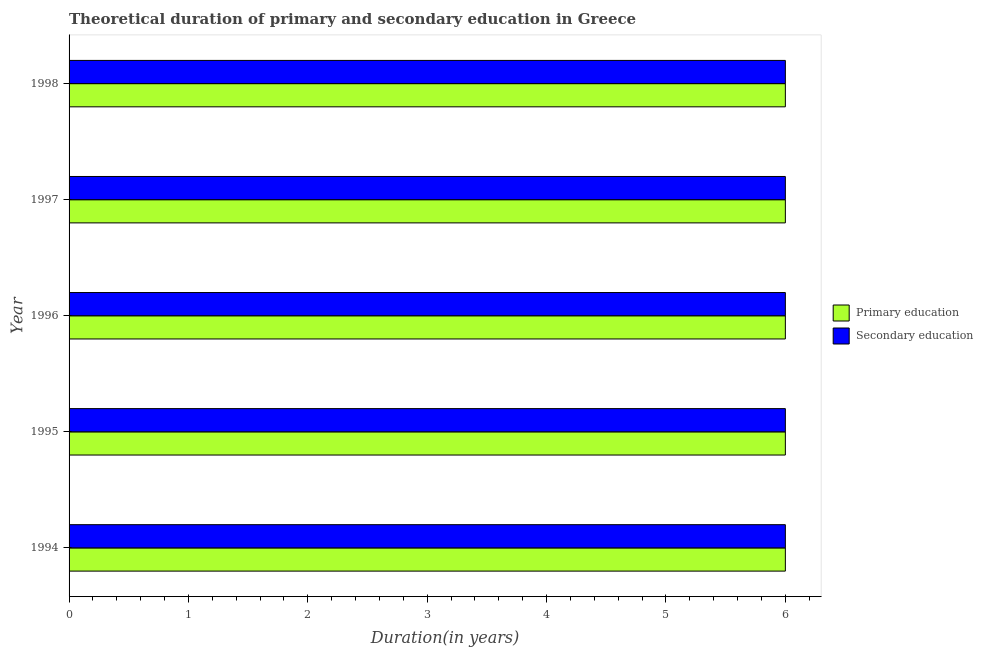How many groups of bars are there?
Keep it short and to the point. 5. Are the number of bars per tick equal to the number of legend labels?
Provide a short and direct response. Yes. How many bars are there on the 3rd tick from the top?
Your answer should be compact. 2. How many bars are there on the 5th tick from the bottom?
Offer a very short reply. 2. What is the label of the 5th group of bars from the top?
Your answer should be compact. 1994. In how many cases, is the number of bars for a given year not equal to the number of legend labels?
Provide a short and direct response. 0. Across all years, what is the minimum duration of secondary education?
Provide a short and direct response. 6. In which year was the duration of secondary education maximum?
Offer a very short reply. 1994. What is the total duration of secondary education in the graph?
Ensure brevity in your answer.  30. What is the average duration of secondary education per year?
Your answer should be compact. 6. In how many years, is the duration of primary education greater than 4.4 years?
Offer a terse response. 5. What is the ratio of the duration of secondary education in 1994 to that in 1995?
Your answer should be very brief. 1. Is the difference between the duration of secondary education in 1996 and 1997 greater than the difference between the duration of primary education in 1996 and 1997?
Make the answer very short. No. In how many years, is the duration of secondary education greater than the average duration of secondary education taken over all years?
Your answer should be compact. 0. What does the 1st bar from the top in 1998 represents?
Your response must be concise. Secondary education. What does the 1st bar from the bottom in 1995 represents?
Keep it short and to the point. Primary education. How many bars are there?
Make the answer very short. 10. Are the values on the major ticks of X-axis written in scientific E-notation?
Offer a very short reply. No. Does the graph contain any zero values?
Your answer should be very brief. No. Does the graph contain grids?
Keep it short and to the point. No. Where does the legend appear in the graph?
Offer a very short reply. Center right. How are the legend labels stacked?
Make the answer very short. Vertical. What is the title of the graph?
Your answer should be compact. Theoretical duration of primary and secondary education in Greece. Does "Net savings(excluding particulate emission damage)" appear as one of the legend labels in the graph?
Keep it short and to the point. No. What is the label or title of the X-axis?
Offer a very short reply. Duration(in years). What is the Duration(in years) of Primary education in 1995?
Provide a succinct answer. 6. What is the Duration(in years) in Secondary education in 1995?
Keep it short and to the point. 6. What is the Duration(in years) of Primary education in 1997?
Your response must be concise. 6. What is the Duration(in years) of Primary education in 1998?
Provide a short and direct response. 6. Across all years, what is the maximum Duration(in years) in Primary education?
Provide a short and direct response. 6. Across all years, what is the maximum Duration(in years) in Secondary education?
Offer a very short reply. 6. Across all years, what is the minimum Duration(in years) of Primary education?
Offer a terse response. 6. What is the total Duration(in years) in Primary education in the graph?
Give a very brief answer. 30. What is the total Duration(in years) in Secondary education in the graph?
Ensure brevity in your answer.  30. What is the difference between the Duration(in years) in Secondary education in 1994 and that in 1995?
Give a very brief answer. 0. What is the difference between the Duration(in years) in Primary education in 1994 and that in 1996?
Provide a short and direct response. 0. What is the difference between the Duration(in years) in Primary education in 1994 and that in 1997?
Your answer should be compact. 0. What is the difference between the Duration(in years) in Secondary education in 1994 and that in 1998?
Your answer should be very brief. 0. What is the difference between the Duration(in years) in Primary education in 1995 and that in 1996?
Provide a short and direct response. 0. What is the difference between the Duration(in years) in Primary education in 1995 and that in 1997?
Your answer should be very brief. 0. What is the difference between the Duration(in years) of Secondary education in 1997 and that in 1998?
Your response must be concise. 0. What is the difference between the Duration(in years) in Primary education in 1994 and the Duration(in years) in Secondary education in 1997?
Provide a short and direct response. 0. What is the difference between the Duration(in years) in Primary education in 1994 and the Duration(in years) in Secondary education in 1998?
Ensure brevity in your answer.  0. What is the difference between the Duration(in years) of Primary education in 1995 and the Duration(in years) of Secondary education in 1996?
Provide a short and direct response. 0. What is the difference between the Duration(in years) of Primary education in 1995 and the Duration(in years) of Secondary education in 1998?
Your answer should be compact. 0. What is the difference between the Duration(in years) in Primary education in 1996 and the Duration(in years) in Secondary education in 1997?
Keep it short and to the point. 0. What is the difference between the Duration(in years) of Primary education in 1996 and the Duration(in years) of Secondary education in 1998?
Provide a succinct answer. 0. What is the difference between the Duration(in years) in Primary education in 1997 and the Duration(in years) in Secondary education in 1998?
Keep it short and to the point. 0. What is the average Duration(in years) of Secondary education per year?
Offer a terse response. 6. In the year 1997, what is the difference between the Duration(in years) of Primary education and Duration(in years) of Secondary education?
Offer a terse response. 0. What is the ratio of the Duration(in years) in Primary education in 1994 to that in 1995?
Make the answer very short. 1. What is the ratio of the Duration(in years) of Secondary education in 1994 to that in 1995?
Your answer should be compact. 1. What is the ratio of the Duration(in years) of Secondary education in 1994 to that in 1996?
Your answer should be compact. 1. What is the ratio of the Duration(in years) in Primary education in 1994 to that in 1997?
Provide a short and direct response. 1. What is the ratio of the Duration(in years) in Primary education in 1994 to that in 1998?
Keep it short and to the point. 1. What is the ratio of the Duration(in years) in Secondary education in 1994 to that in 1998?
Make the answer very short. 1. What is the ratio of the Duration(in years) in Secondary education in 1995 to that in 1997?
Your response must be concise. 1. What is the difference between the highest and the second highest Duration(in years) in Primary education?
Keep it short and to the point. 0. What is the difference between the highest and the second highest Duration(in years) in Secondary education?
Provide a short and direct response. 0. 